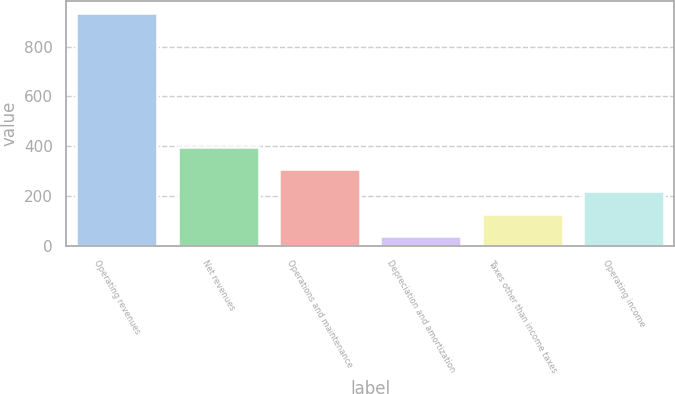Convert chart. <chart><loc_0><loc_0><loc_500><loc_500><bar_chart><fcel>Operating revenues<fcel>Net revenues<fcel>Operations and maintenance<fcel>Depreciation and amortization<fcel>Taxes other than income taxes<fcel>Operating income<nl><fcel>936<fcel>397.2<fcel>307.4<fcel>38<fcel>127.8<fcel>217.6<nl></chart> 